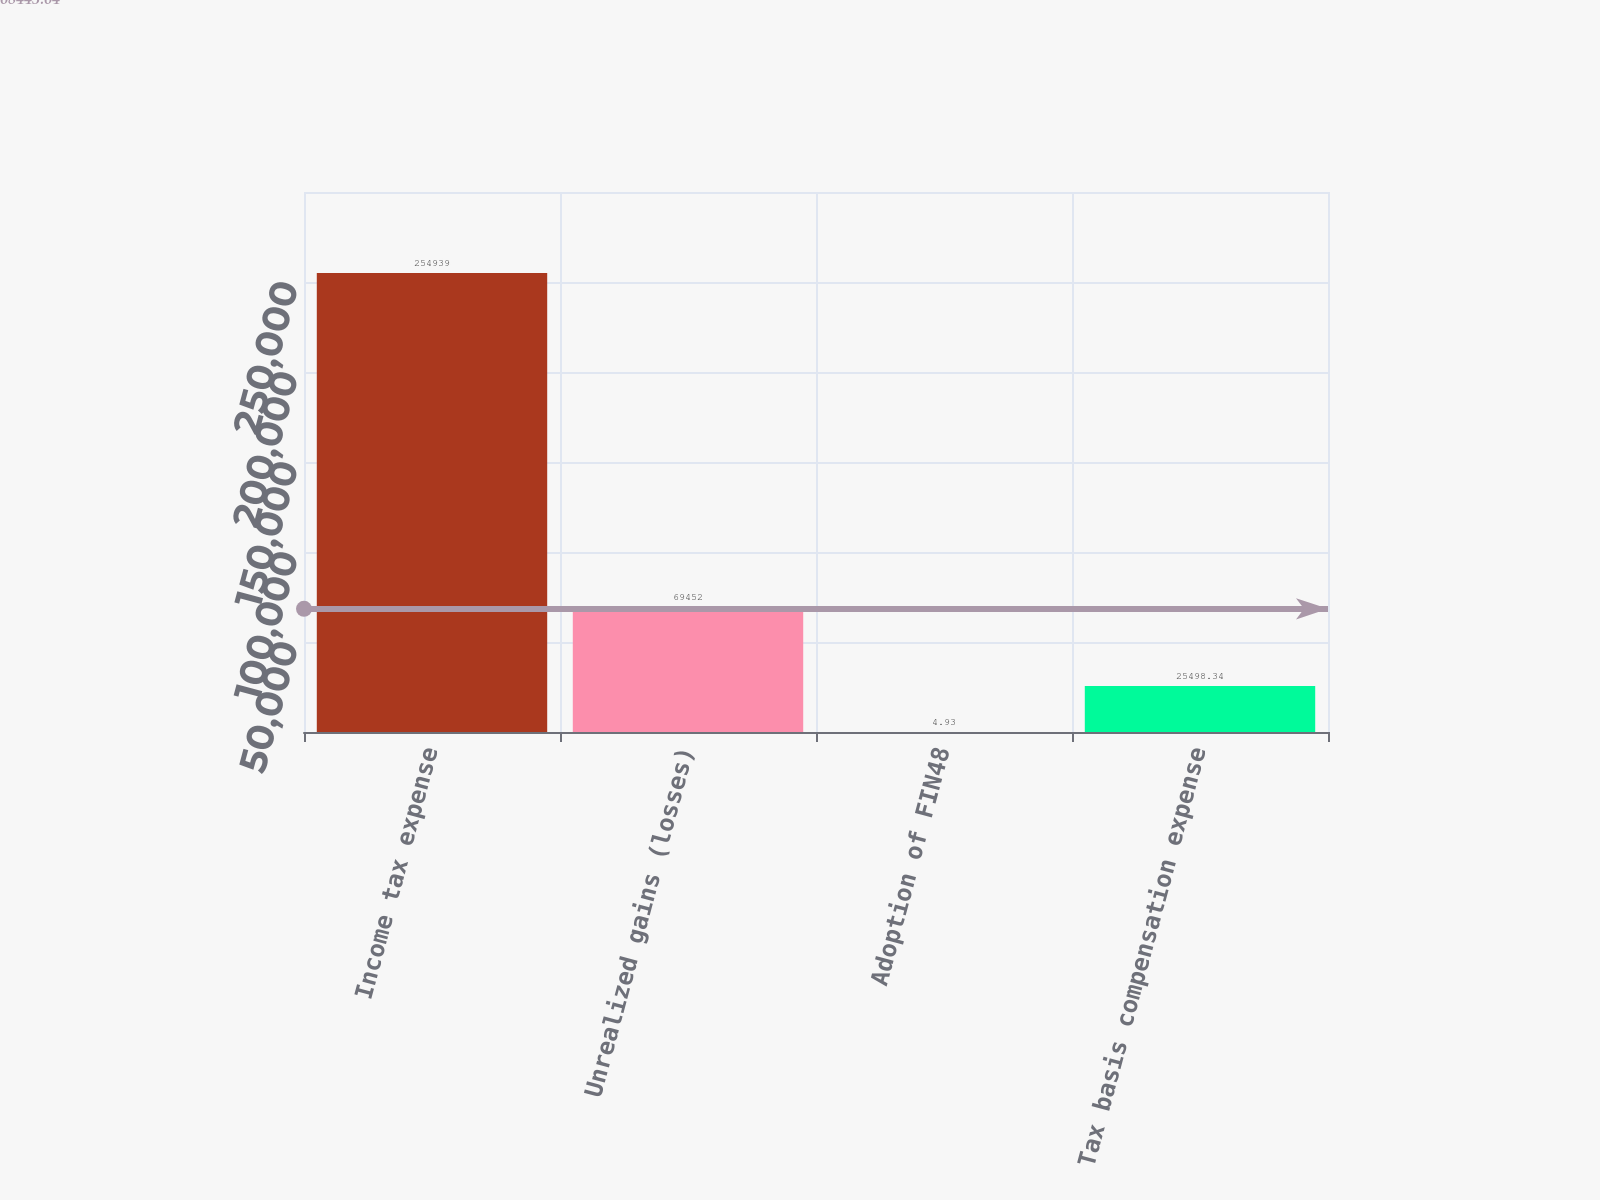Convert chart to OTSL. <chart><loc_0><loc_0><loc_500><loc_500><bar_chart><fcel>Income tax expense<fcel>Unrealized gains (losses)<fcel>Adoption of FIN48<fcel>Tax basis compensation expense<nl><fcel>254939<fcel>69452<fcel>4.93<fcel>25498.3<nl></chart> 